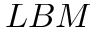Convert formula to latex. <formula><loc_0><loc_0><loc_500><loc_500>L B M</formula> 